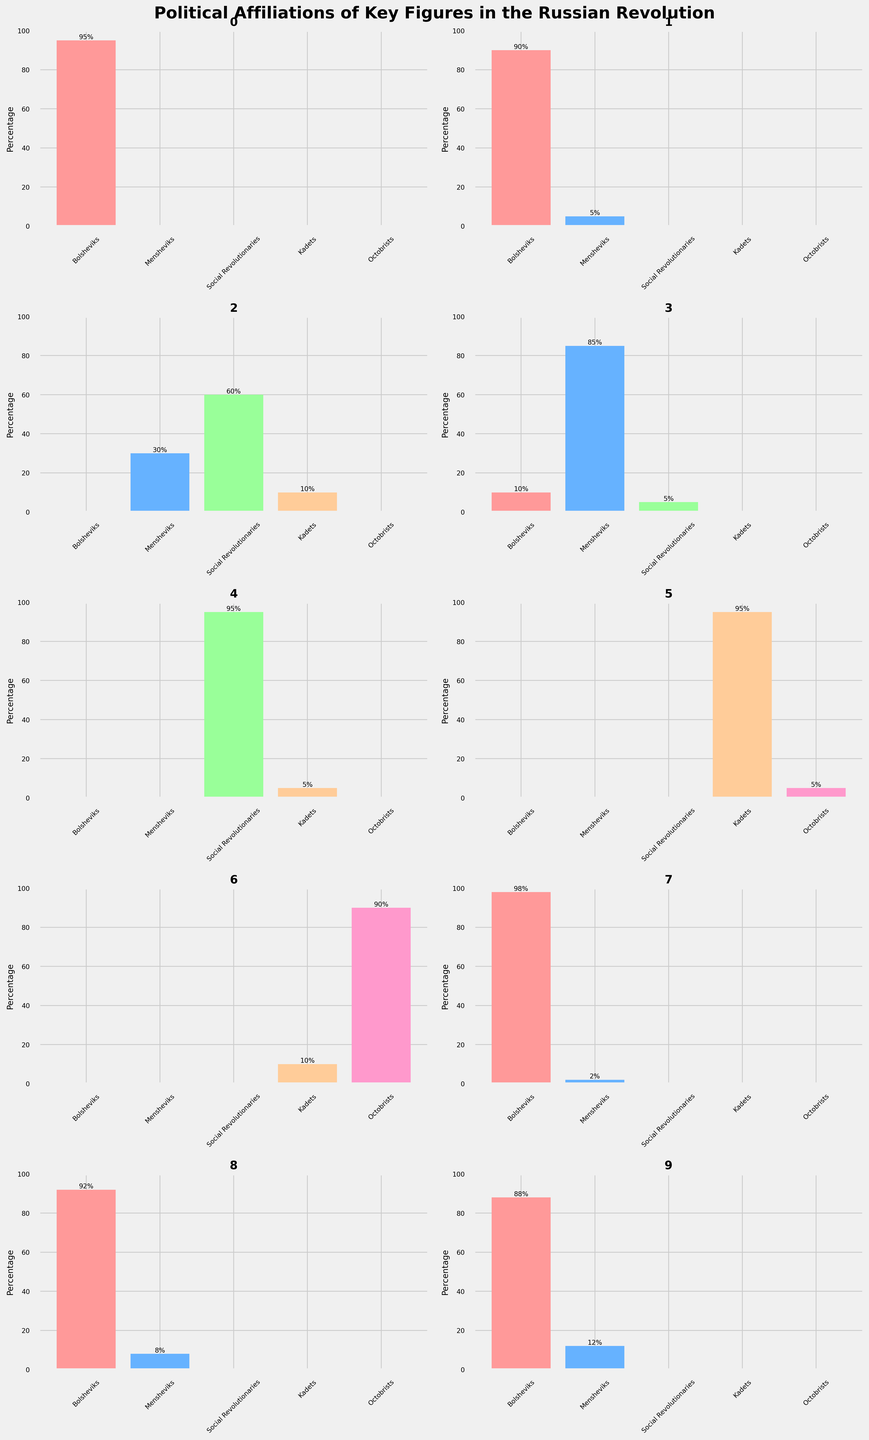What are the political affiliations highlighted in the plot? The plot shows bar charts with percentages for different political affiliations: Bolsheviks, Mensheviks, Social Revolutionaries, Kadets, and Octobrists.
Answer: Bolsheviks, Mensheviks, Social Revolutionaries, Kadets, Octobrists Who is the key figure with the highest percentage of Bolshevik affiliation? By looking at the Bolshevik percentages in the bar charts, the highest percentage is attributed to Joseph Stalin with 98%.
Answer: Joseph Stalin How many individuals have their highest affiliation with the Mensheviks? By counting the bar charts, Julius Martov (85%) and Leon Trotsky (5%) have Mensheviks as their highest affiliation.
Answer: 2 Which key figure has the most diverse political affiliations? Alexander Kerensky has all five political affiliations with varying percentages: 0% Bolsheviks, 30% Mensheviks, 60% Social Revolutionaries, 10% Kadets, and 0% Octobrists.
Answer: Alexander Kerensky What is the average percentage affiliation with the Social Revolutionaries among the key figures? Adding the Social Revolutionaries percentages: 0% (Vladimir Lenin) + 0% (Leon Trotsky) + 60% (Alexander Kerensky) + 5% (Julius Martov) + 95% (Victor Chernov) + 0% (Pavel Milyukov) + 0% (Alexander Guchkov) + 0% (Joseph Stalin) + 0% (Grigory Zinoviev) + 0% (Lev Kamenev) = 160%, and there are 10 figures, so 160% / 10 = 16%.
Answer: 16% Between Bolsheviks and Mensheviks, which group has more key figures with a majority affiliation (greater than 50%)? Bolsheviks: Vladimir Lenin, Leon Trotsky, Joseph Stalin, Grigory Zinoviev, Lev Kamenev (5 figures). Mensheviks: Julius Martov (1 figure).
Answer: Bolsheviks How many key figures have no affiliation with the Kadets? Counting the figures with 0% for Kadets: Vladimir Lenin, Leon Trotsky, Joseph Stalin, Grigory Zinoviev, Lev Kamenev, Julius Martov (Mensheviks, 5%).
Answer: 6 Compare the affiliation percentage of Simonov and Kiryusha with the Bolsheviks. Who has a higher value? Simonov is not a key figure in the provided data. For Kiryusha, the name doesn’t appear either. Therefore, this information cannot be concluded from the figure.
Answer: N/A What is the sum of the percentages of Bolshevik affiliation for all key figures? Adding the Bolshevik percentages: 95% (Vladimir Lenin) + 90% (Leon Trotsky) + 0% (Alexander Kerensky) + 10% (Julius Martov) + 0% (Victor Chernov) + 0% (Pavel Milyukov) + 0% (Alexander Guchkov) + 98% (Joseph Stalin) + 92% (Grigory Zinoviev) + 88% (Lev Kamenev) = 473%.
Answer: 473% Which key figure has the highest percentage of affiliation with the Kadets? By looking at the Kadets percentages, Pavel Milyukov has the highest percentage with 95%.
Answer: Pavel Milyukov 